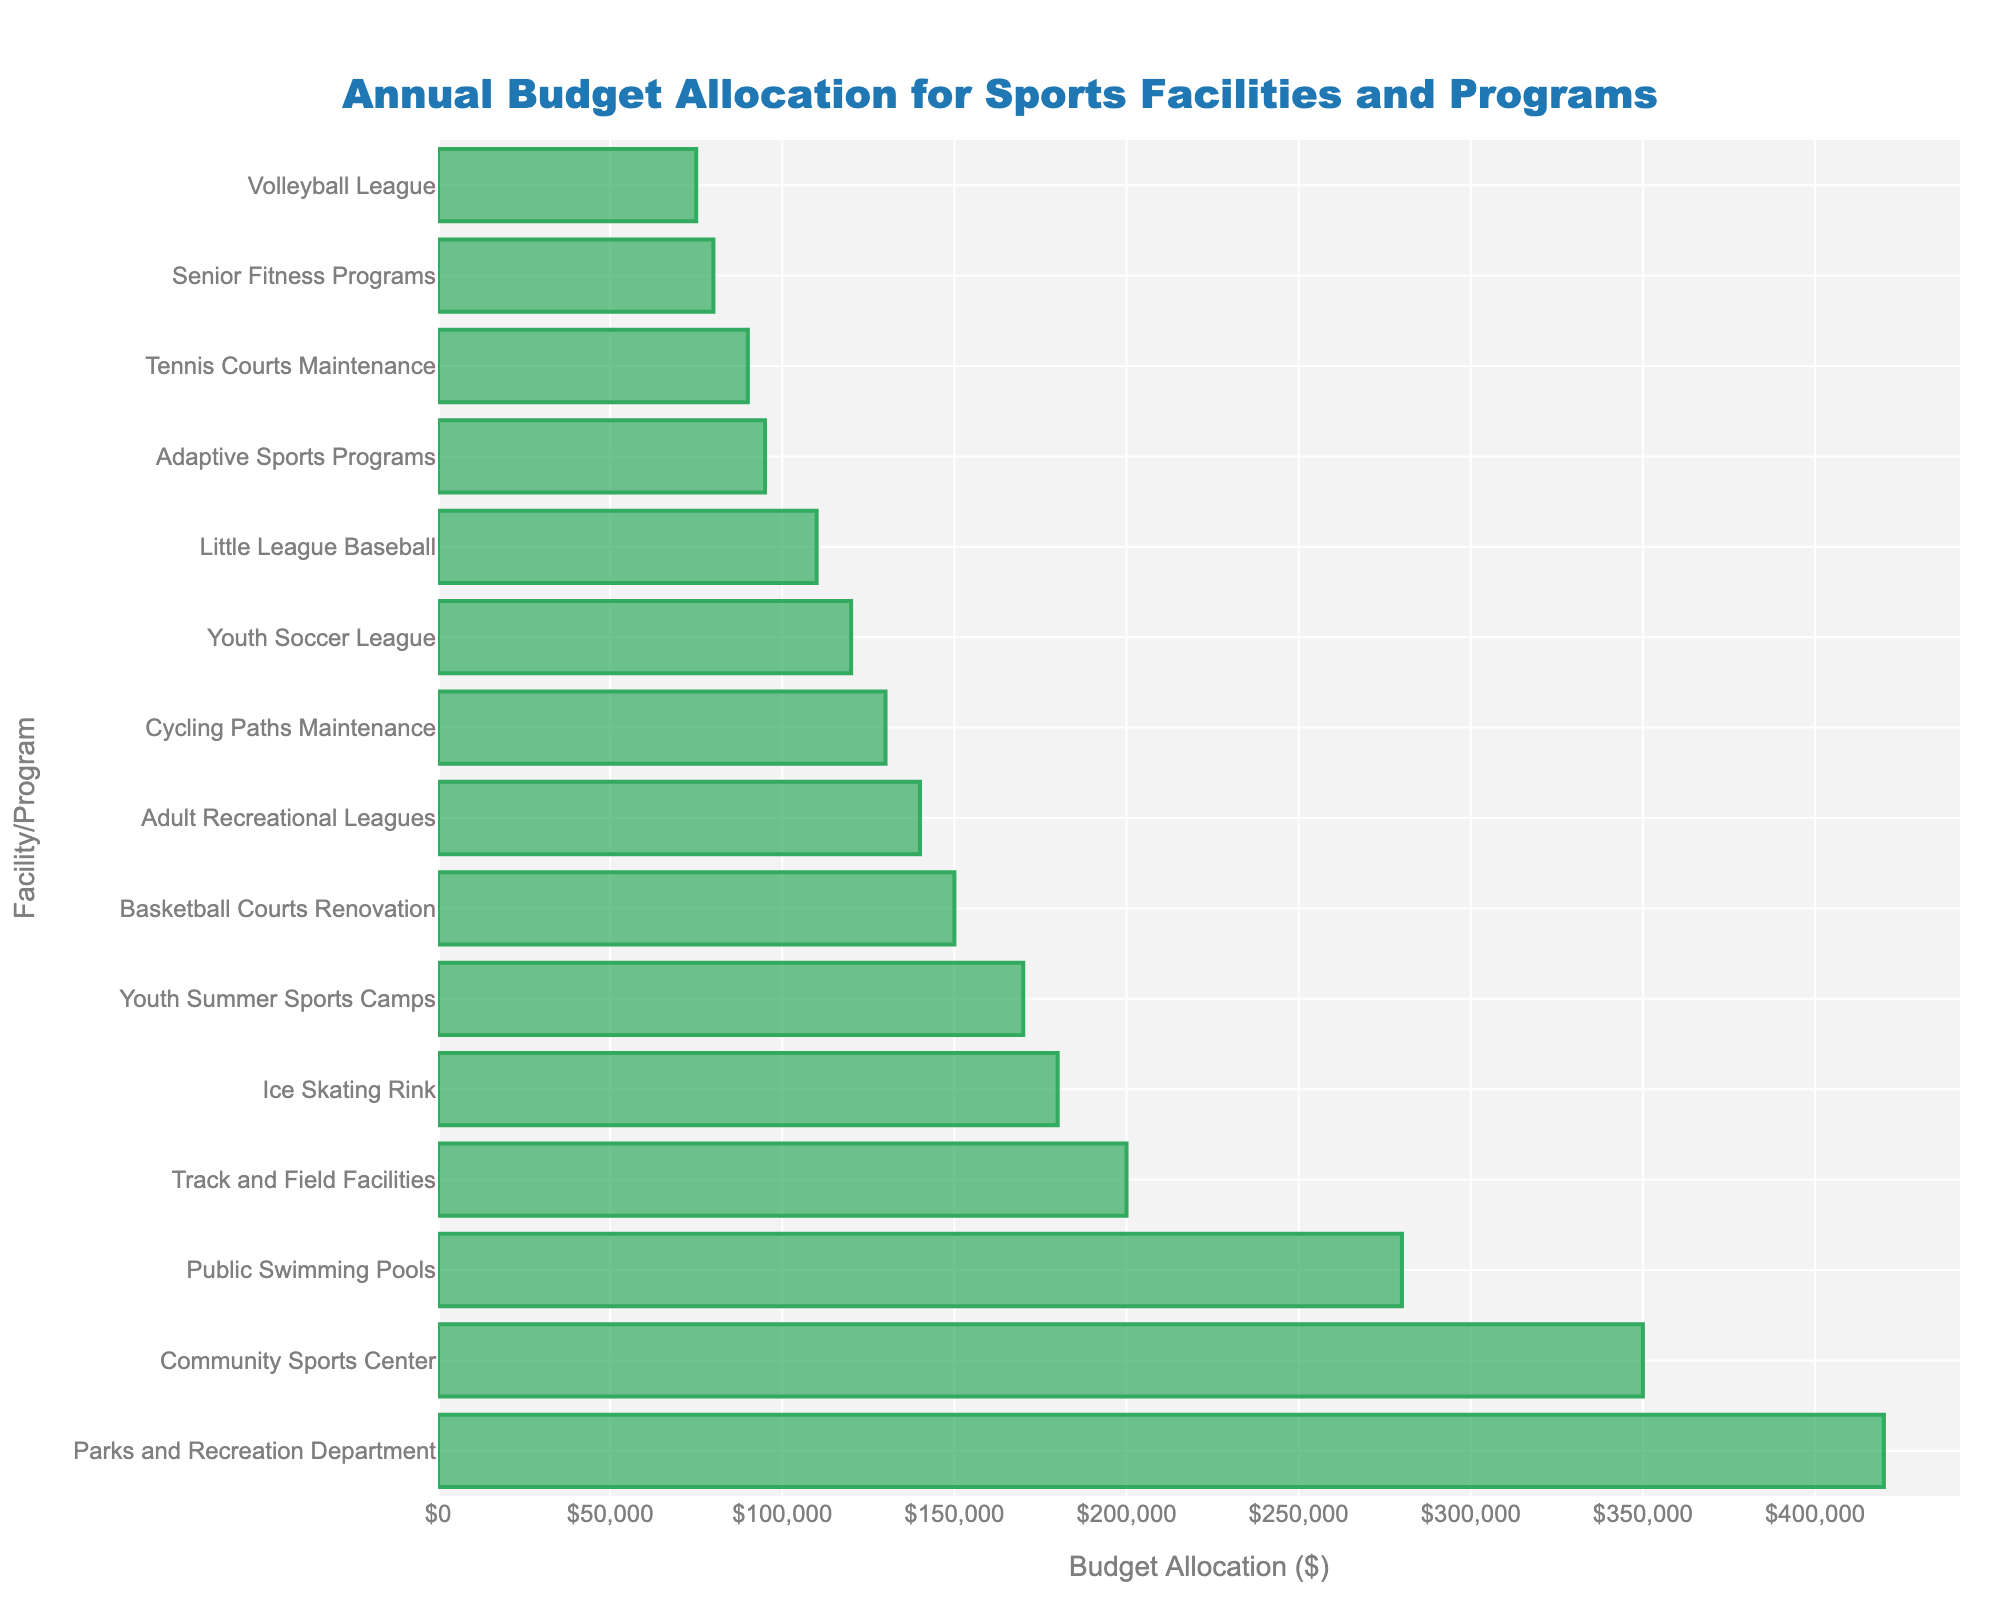what is the total budget allocation for the Community Sports Center, Public Swimming Pools, and Parks and Recreation Department? Add the budget allocations for these facilities: Community Sports Center ($350,000) + Public Swimming Pools ($280,000) + Parks and Recreation Department ($420,000) = $350,000 + $280,000 + $420,000 = $1,050,000
Answer: $1,050,000 Which facility or program has the lowest budget allocation? Look at the bar chart and find the shortest bar, which represents the facility or program with the lowest budget allocation. The shortest bar is for the Volleyball League.
Answer: Volleyball League Is the budget allocation for Youth Summer Sports Camps greater than the allocation for Adaptive Sports Programs? Compare the lengths of the bars for Youth Summer Sports Camps and Adaptive Sports Programs. Youth Summer Sports Camps has a budget of $170,000, while Adaptive Sports Programs has a budget of $95,000. Therefore, the allocation for Youth Summer Sports Camps is greater.
Answer: Yes What is the difference in budget between the Ice Skating Rink and the Basketball Courts Renovation? Subtract the budget for Basketball Courts Renovation ($150,000) from the budget for the Ice Skating Rink ($180,000): $180,000 - $150,000 = $30,000
Answer: $30,000 What is the average budget allocation for the top three facilities/programs? The top three facilities/programs by budget allocation are Parks and Recreation Department ($420,000), Community Sports Center ($350,000), and Public Swimming Pools ($280,000). Find the average by summing these values and dividing by 3: ($420,000 + $350,000 + $280,000) / 3 = $1,050,000 / 3 = $350,000
Answer: $350,000 How many facilities or programs have a budget allocation of at least $200,000? Count the number of bars that represent at least $200,000 in budget allocation. They are Parks and Recreation Department, Community Sports Center, Public Swimming Pools, Track and Field Facilities, and Ice Skating Rink. There are 5 in total.
Answer: 5 Which has a higher budget allocation: Adult Recreational Leagues or Youth Soccer League? Compare the bars for Adult Recreational Leagues and Youth Soccer League. The budget for Adult Recreational Leagues is $140,000, while the Youth Soccer League is $120,000. Thus, Adult Recreational Leagues has a higher budget allocation.
Answer: Adult Recreational Leagues Identify two facilities or programs that have budget allocations between $100,000 and $150,000. Examine the bars that fall between $100,000 and $150,000. The facilities or programs within this range are Little League Baseball ($110,000) and Cycling Paths Maintenance ($130,000).
Answer: Little League Baseball, Cycling Paths Maintenance What is the combined budget allocation for youth-focused programs (Youth Soccer League, Youth Summer Sports Camps, and Little League Baseball)? Add the budget allocations for these youth-focused programs: Youth Soccer League ($120,000) + Youth Summer Sports Camps ($170,000) + Little League Baseball ($110,000) = $120,000 + $170,000 + $110,000 = $400,000
Answer: $400,000 